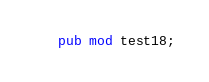Convert code to text. <code><loc_0><loc_0><loc_500><loc_500><_Rust_>pub mod test18;</code> 